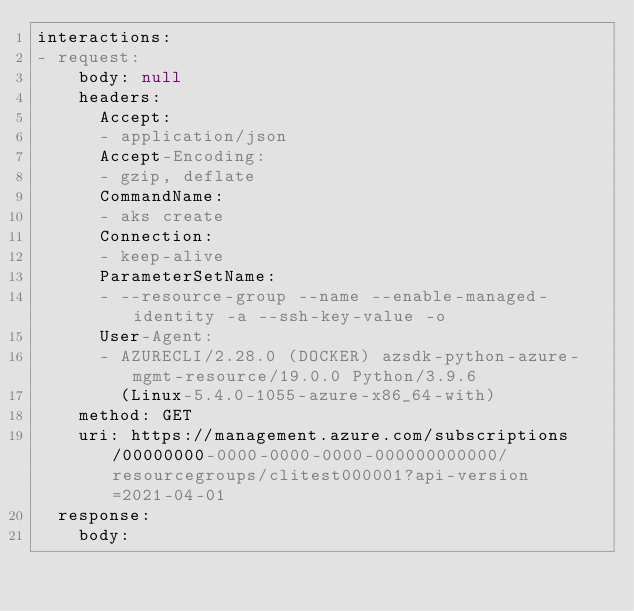Convert code to text. <code><loc_0><loc_0><loc_500><loc_500><_YAML_>interactions:
- request:
    body: null
    headers:
      Accept:
      - application/json
      Accept-Encoding:
      - gzip, deflate
      CommandName:
      - aks create
      Connection:
      - keep-alive
      ParameterSetName:
      - --resource-group --name --enable-managed-identity -a --ssh-key-value -o
      User-Agent:
      - AZURECLI/2.28.0 (DOCKER) azsdk-python-azure-mgmt-resource/19.0.0 Python/3.9.6
        (Linux-5.4.0-1055-azure-x86_64-with)
    method: GET
    uri: https://management.azure.com/subscriptions/00000000-0000-0000-0000-000000000000/resourcegroups/clitest000001?api-version=2021-04-01
  response:
    body:</code> 